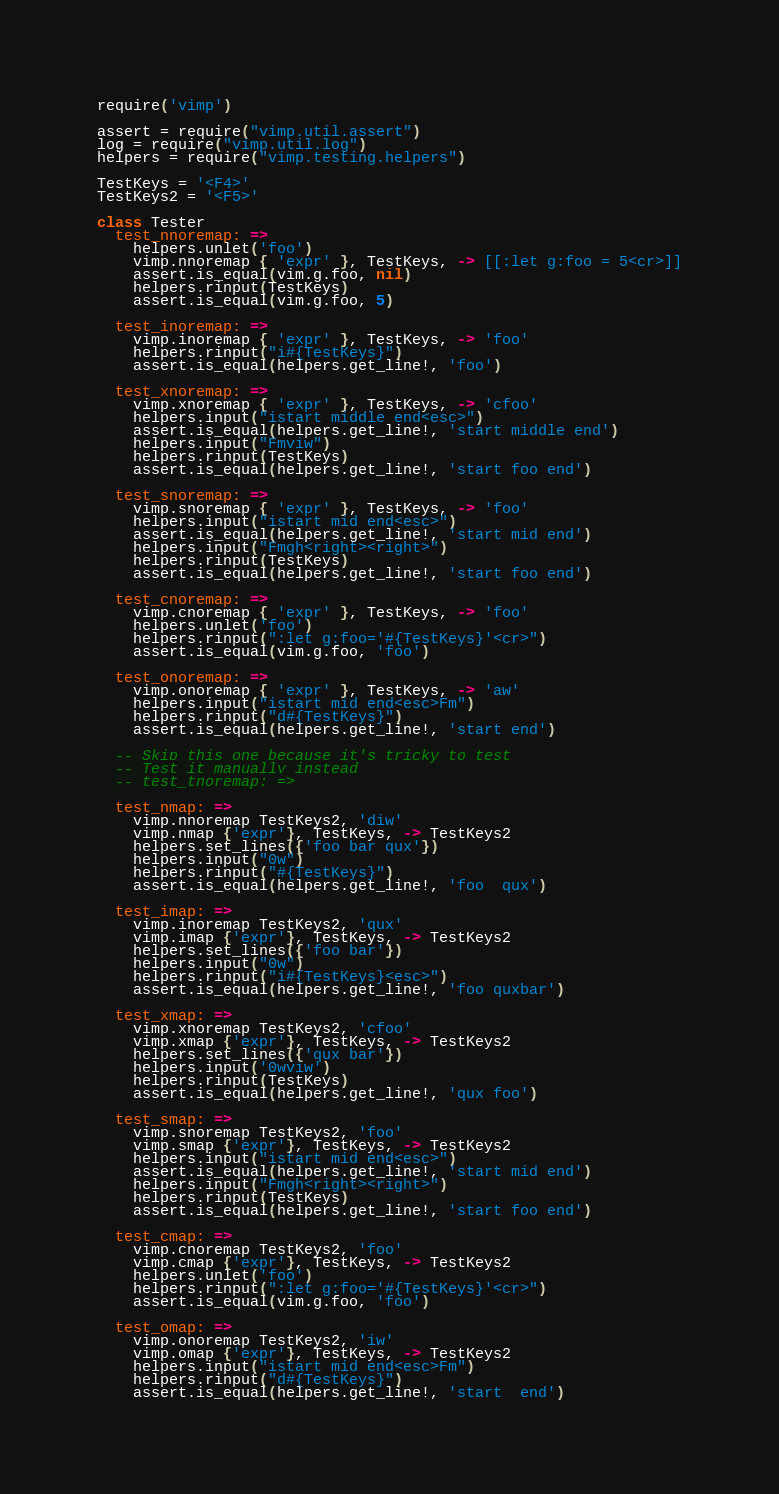Convert code to text. <code><loc_0><loc_0><loc_500><loc_500><_MoonScript_>
require('vimp')

assert = require("vimp.util.assert")
log = require("vimp.util.log")
helpers = require("vimp.testing.helpers")

TestKeys = '<F4>'
TestKeys2 = '<F5>'

class Tester
  test_nnoremap: =>
    helpers.unlet('foo')
    vimp.nnoremap { 'expr' }, TestKeys, -> [[:let g:foo = 5<cr>]]
    assert.is_equal(vim.g.foo, nil)
    helpers.rinput(TestKeys)
    assert.is_equal(vim.g.foo, 5)

  test_inoremap: =>
    vimp.inoremap { 'expr' }, TestKeys, -> 'foo'
    helpers.rinput("i#{TestKeys}")
    assert.is_equal(helpers.get_line!, 'foo')

  test_xnoremap: =>
    vimp.xnoremap { 'expr' }, TestKeys, -> 'cfoo'
    helpers.input("istart middle end<esc>")
    assert.is_equal(helpers.get_line!, 'start middle end')
    helpers.input("Fmviw")
    helpers.rinput(TestKeys)
    assert.is_equal(helpers.get_line!, 'start foo end')

  test_snoremap: =>
    vimp.snoremap { 'expr' }, TestKeys, -> 'foo'
    helpers.input("istart mid end<esc>")
    assert.is_equal(helpers.get_line!, 'start mid end')
    helpers.input("Fmgh<right><right>")
    helpers.rinput(TestKeys)
    assert.is_equal(helpers.get_line!, 'start foo end')

  test_cnoremap: =>
    vimp.cnoremap { 'expr' }, TestKeys, -> 'foo'
    helpers.unlet('foo')
    helpers.rinput(":let g:foo='#{TestKeys}'<cr>")
    assert.is_equal(vim.g.foo, 'foo')

  test_onoremap: =>
    vimp.onoremap { 'expr' }, TestKeys, -> 'aw'
    helpers.input("istart mid end<esc>Fm")
    helpers.rinput("d#{TestKeys}")
    assert.is_equal(helpers.get_line!, 'start end')

  -- Skip this one because it's tricky to test
  -- Test it manually instead
  -- test_tnoremap: =>

  test_nmap: =>
    vimp.nnoremap TestKeys2, 'diw'
    vimp.nmap {'expr'}, TestKeys, -> TestKeys2
    helpers.set_lines({'foo bar qux'})
    helpers.input("0w")
    helpers.rinput("#{TestKeys}")
    assert.is_equal(helpers.get_line!, 'foo  qux')

  test_imap: =>
    vimp.inoremap TestKeys2, 'qux'
    vimp.imap {'expr'}, TestKeys, -> TestKeys2
    helpers.set_lines({'foo bar'})
    helpers.input("0w")
    helpers.rinput("i#{TestKeys}<esc>")
    assert.is_equal(helpers.get_line!, 'foo quxbar')

  test_xmap: =>
    vimp.xnoremap TestKeys2, 'cfoo'
    vimp.xmap {'expr'}, TestKeys, -> TestKeys2
    helpers.set_lines({'qux bar'})
    helpers.input('0wviw')
    helpers.rinput(TestKeys)
    assert.is_equal(helpers.get_line!, 'qux foo')

  test_smap: =>
    vimp.snoremap TestKeys2, 'foo'
    vimp.smap {'expr'}, TestKeys, -> TestKeys2
    helpers.input("istart mid end<esc>")
    assert.is_equal(helpers.get_line!, 'start mid end')
    helpers.input("Fmgh<right><right>")
    helpers.rinput(TestKeys)
    assert.is_equal(helpers.get_line!, 'start foo end')

  test_cmap: =>
    vimp.cnoremap TestKeys2, 'foo'
    vimp.cmap {'expr'}, TestKeys, -> TestKeys2
    helpers.unlet('foo')
    helpers.rinput(":let g:foo='#{TestKeys}'<cr>")
    assert.is_equal(vim.g.foo, 'foo')

  test_omap: =>
    vimp.onoremap TestKeys2, 'iw'
    vimp.omap {'expr'}, TestKeys, -> TestKeys2
    helpers.input("istart mid end<esc>Fm")
    helpers.rinput("d#{TestKeys}")
    assert.is_equal(helpers.get_line!, 'start  end')
</code> 